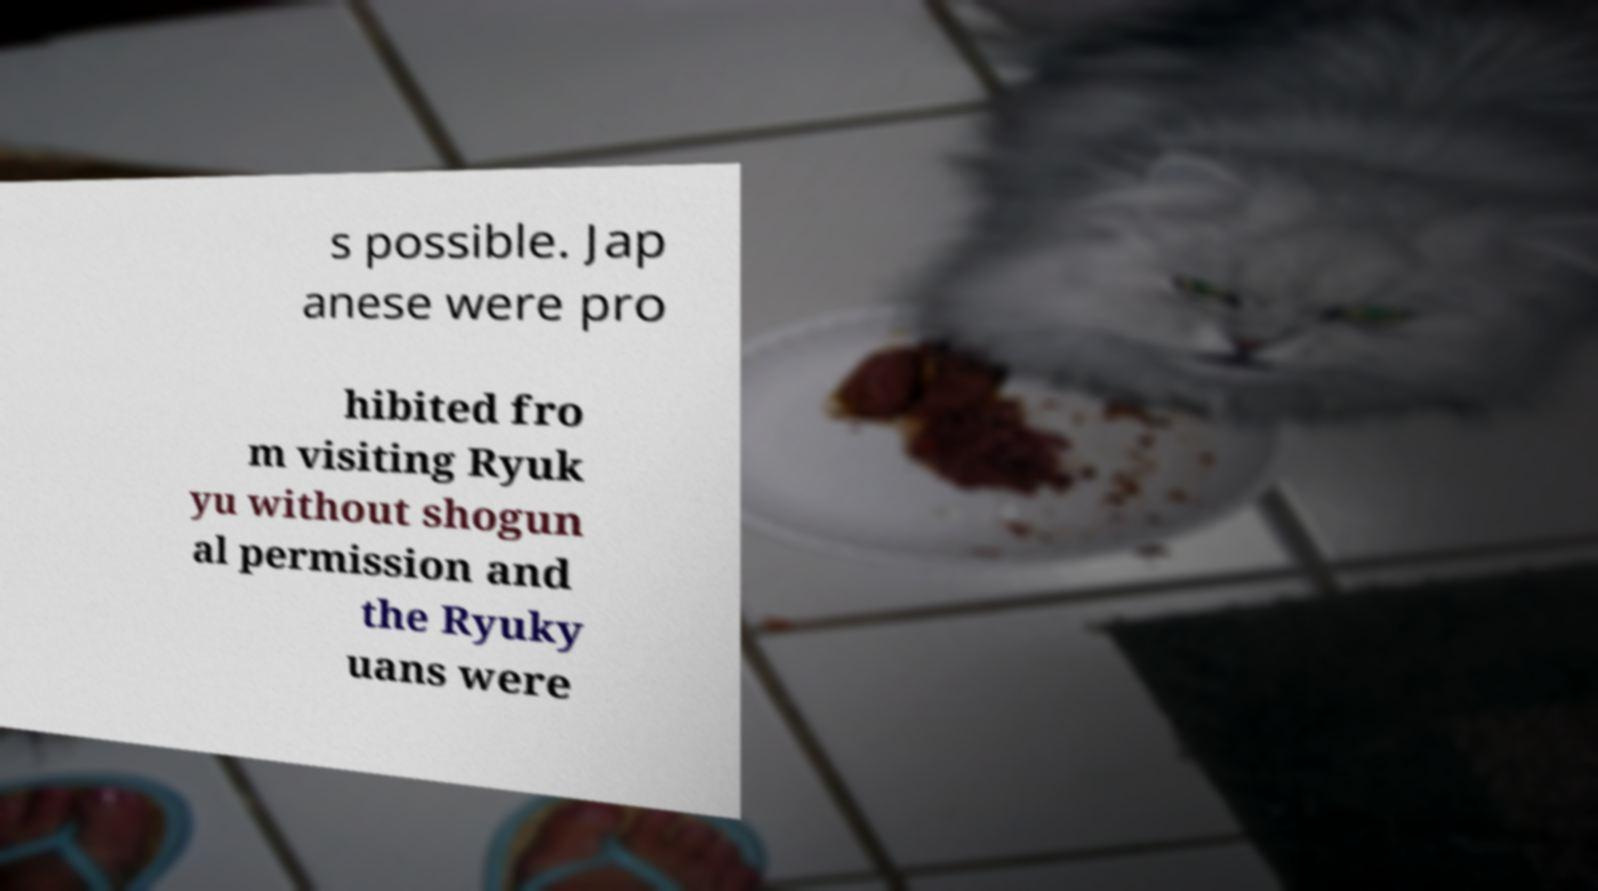Please identify and transcribe the text found in this image. s possible. Jap anese were pro hibited fro m visiting Ryuk yu without shogun al permission and the Ryuky uans were 